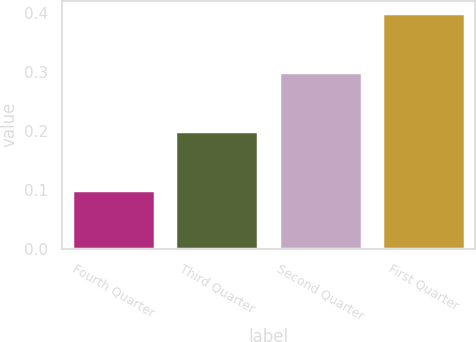Convert chart to OTSL. <chart><loc_0><loc_0><loc_500><loc_500><bar_chart><fcel>Fourth Quarter<fcel>Third Quarter<fcel>Second Quarter<fcel>First Quarter<nl><fcel>0.1<fcel>0.2<fcel>0.3<fcel>0.4<nl></chart> 